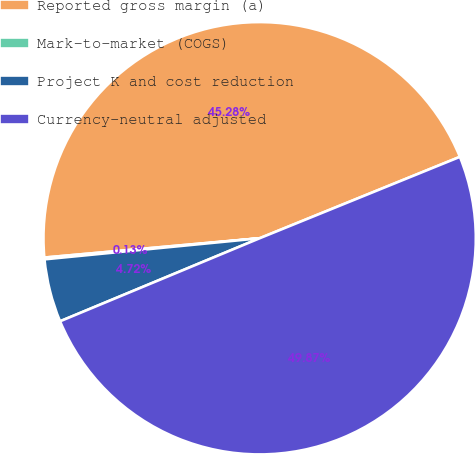Convert chart. <chart><loc_0><loc_0><loc_500><loc_500><pie_chart><fcel>Reported gross margin (a)<fcel>Mark-to-market (COGS)<fcel>Project K and cost reduction<fcel>Currency-neutral adjusted<nl><fcel>45.28%<fcel>0.13%<fcel>4.72%<fcel>49.87%<nl></chart> 